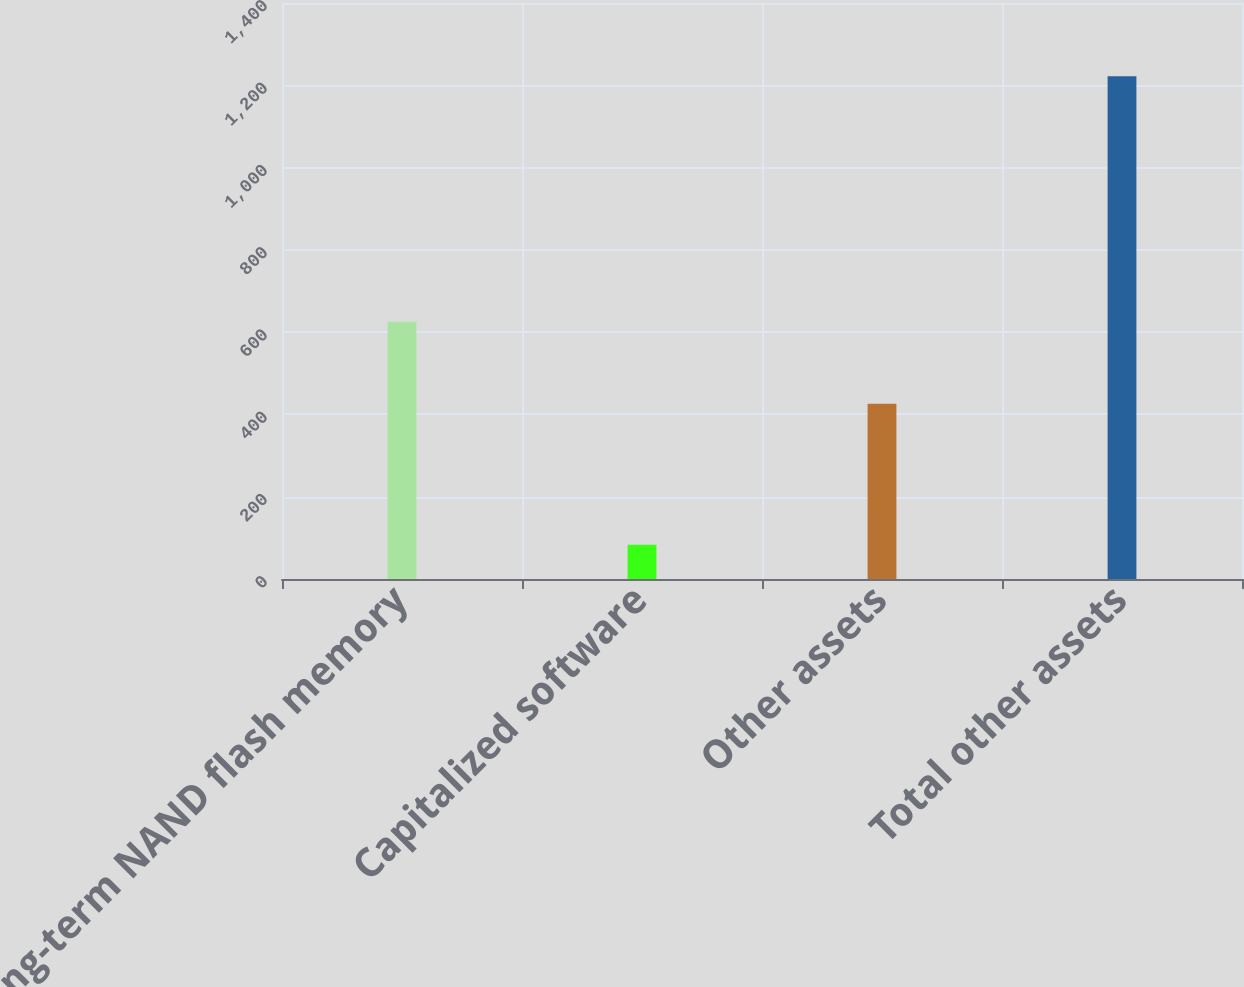Convert chart to OTSL. <chart><loc_0><loc_0><loc_500><loc_500><bar_chart><fcel>Long-term NAND flash memory<fcel>Capitalized software<fcel>Other assets<fcel>Total other assets<nl><fcel>625<fcel>83<fcel>426<fcel>1222<nl></chart> 